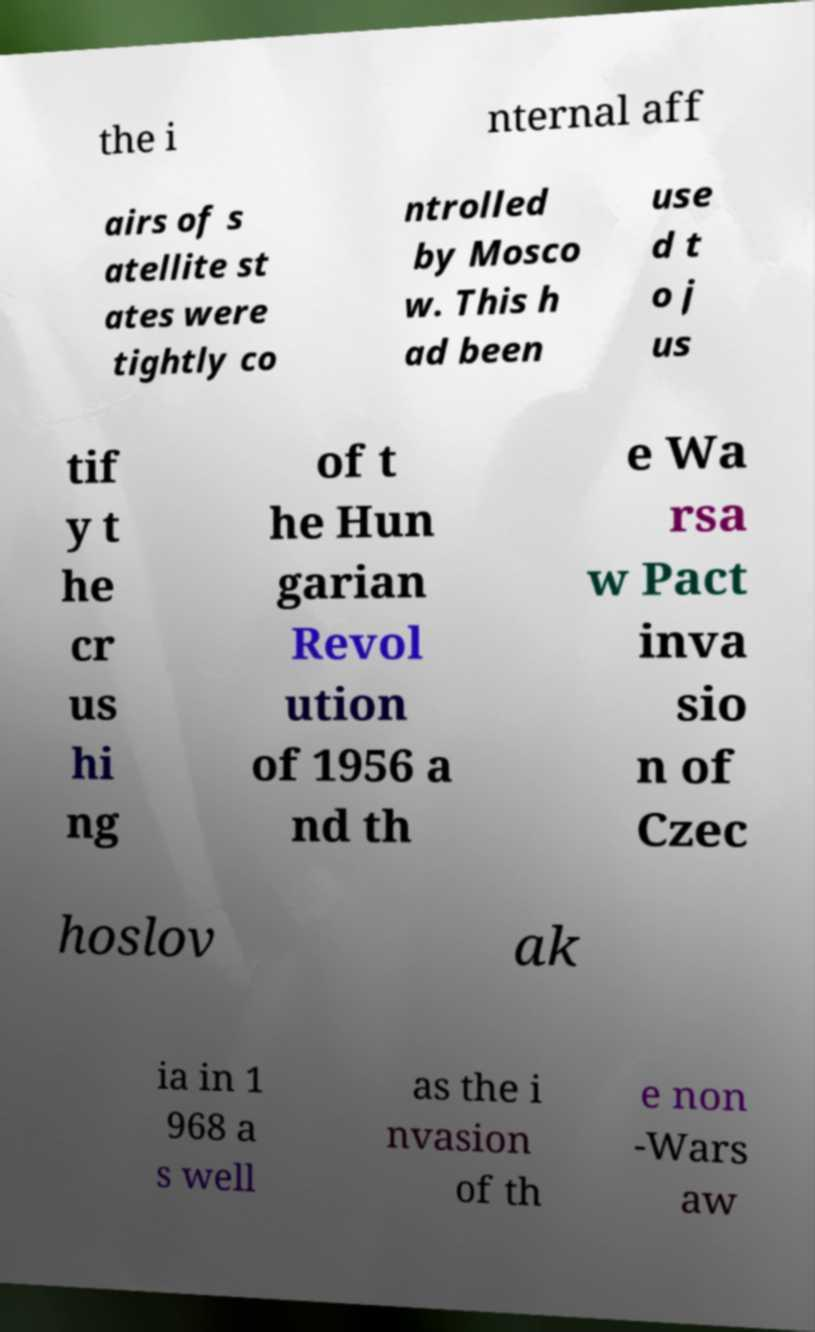Can you accurately transcribe the text from the provided image for me? the i nternal aff airs of s atellite st ates were tightly co ntrolled by Mosco w. This h ad been use d t o j us tif y t he cr us hi ng of t he Hun garian Revol ution of 1956 a nd th e Wa rsa w Pact inva sio n of Czec hoslov ak ia in 1 968 a s well as the i nvasion of th e non -Wars aw 